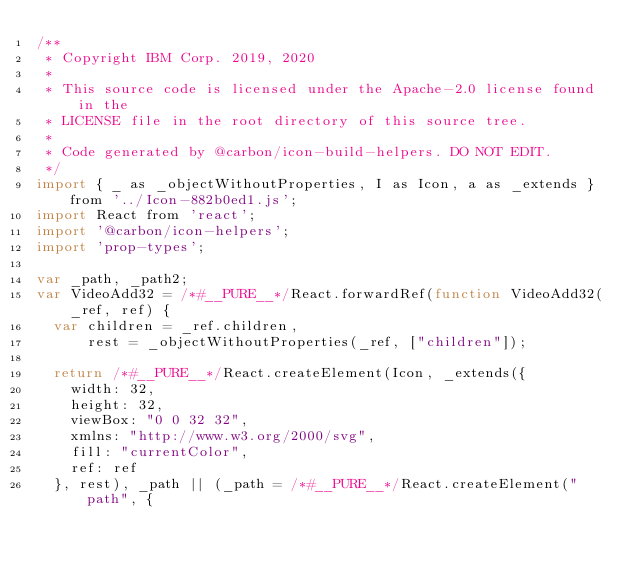<code> <loc_0><loc_0><loc_500><loc_500><_JavaScript_>/**
 * Copyright IBM Corp. 2019, 2020
 *
 * This source code is licensed under the Apache-2.0 license found in the
 * LICENSE file in the root directory of this source tree.
 *
 * Code generated by @carbon/icon-build-helpers. DO NOT EDIT.
 */
import { _ as _objectWithoutProperties, I as Icon, a as _extends } from '../Icon-882b0ed1.js';
import React from 'react';
import '@carbon/icon-helpers';
import 'prop-types';

var _path, _path2;
var VideoAdd32 = /*#__PURE__*/React.forwardRef(function VideoAdd32(_ref, ref) {
  var children = _ref.children,
      rest = _objectWithoutProperties(_ref, ["children"]);

  return /*#__PURE__*/React.createElement(Icon, _extends({
    width: 32,
    height: 32,
    viewBox: "0 0 32 32",
    xmlns: "http://www.w3.org/2000/svg",
    fill: "currentColor",
    ref: ref
  }, rest), _path || (_path = /*#__PURE__*/React.createElement("path", {</code> 